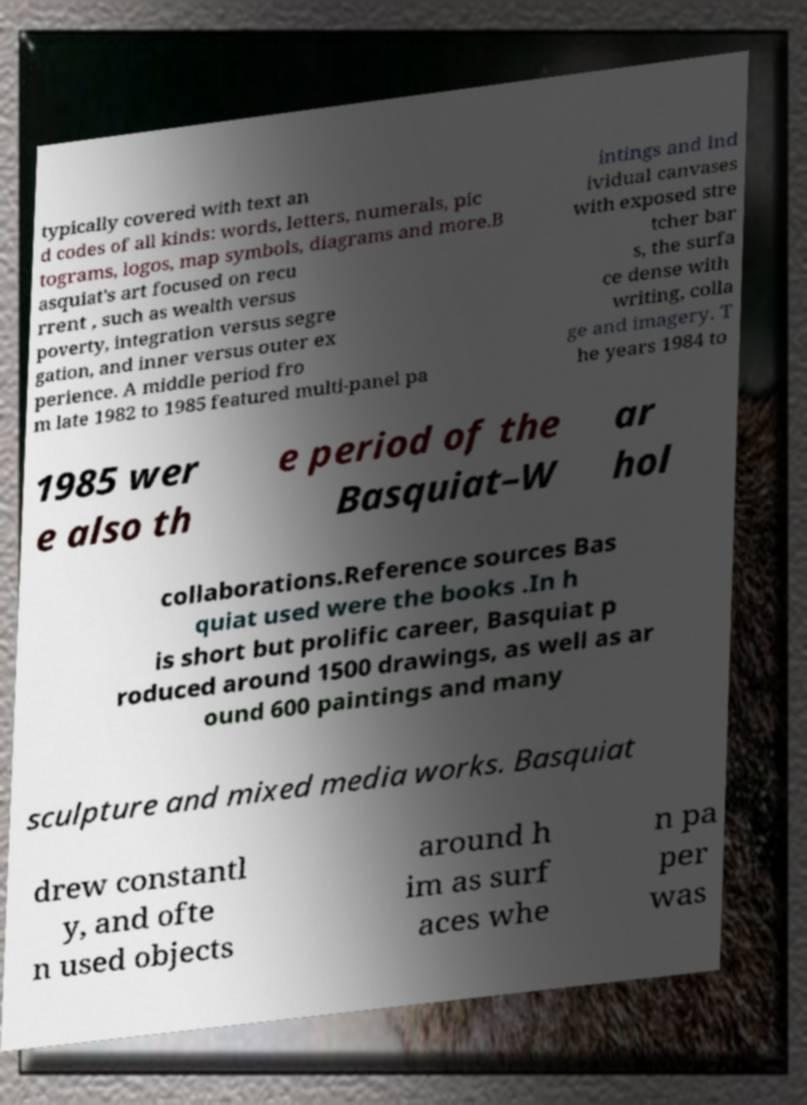For documentation purposes, I need the text within this image transcribed. Could you provide that? typically covered with text an d codes of all kinds: words, letters, numerals, pic tograms, logos, map symbols, diagrams and more.B asquiat's art focused on recu rrent , such as wealth versus poverty, integration versus segre gation, and inner versus outer ex perience. A middle period fro m late 1982 to 1985 featured multi-panel pa intings and ind ividual canvases with exposed stre tcher bar s, the surfa ce dense with writing, colla ge and imagery. T he years 1984 to 1985 wer e also th e period of the Basquiat–W ar hol collaborations.Reference sources Bas quiat used were the books .In h is short but prolific career, Basquiat p roduced around 1500 drawings, as well as ar ound 600 paintings and many sculpture and mixed media works. Basquiat drew constantl y, and ofte n used objects around h im as surf aces whe n pa per was 